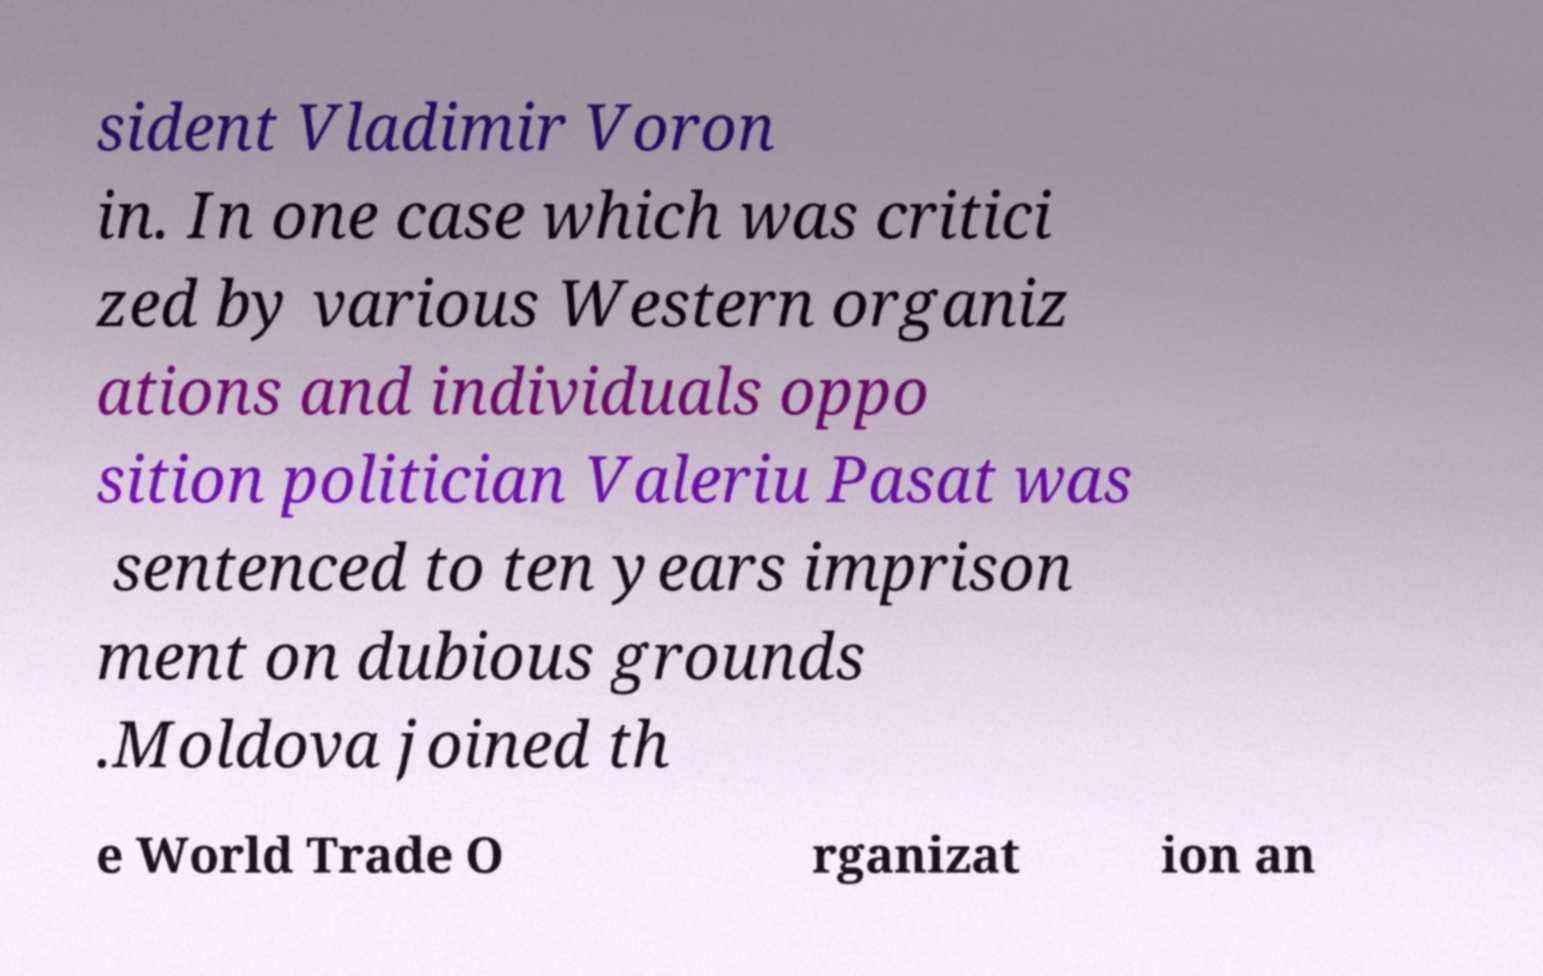Can you read and provide the text displayed in the image?This photo seems to have some interesting text. Can you extract and type it out for me? sident Vladimir Voron in. In one case which was critici zed by various Western organiz ations and individuals oppo sition politician Valeriu Pasat was sentenced to ten years imprison ment on dubious grounds .Moldova joined th e World Trade O rganizat ion an 